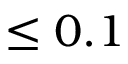Convert formula to latex. <formula><loc_0><loc_0><loc_500><loc_500>\leq 0 . 1</formula> 